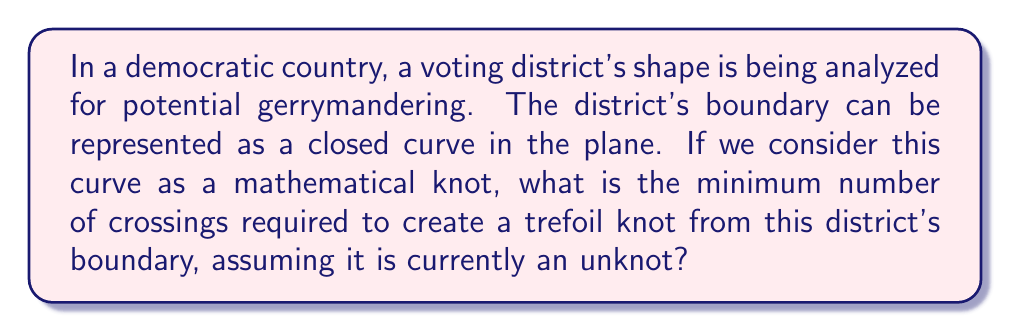Teach me how to tackle this problem. To approach this problem, we need to consider the following steps:

1. Understand the current state:
   The district's boundary is represented as an unknot, which is a simple closed curve with no crossings.

2. Define the goal:
   We want to transform the unknot into a trefoil knot, which is the simplest non-trivial knot.

3. Recall the properties of a trefoil knot:
   A trefoil knot has a minimum crossing number of 3. This means that in any projection of the trefoil knot onto a plane, there will be at least 3 crossings.

4. Consider the transformation:
   To change the unknot into a trefoil knot, we need to introduce crossings. Each crossing requires two separate parts of the curve to intersect.

5. Calculate the minimum number of crossings:
   Since the trefoil knot has a minimum crossing number of 3, and we're starting from an unknot (which has 0 crossings), we need to add at least 3 crossings to create a trefoil knot.

6. Interpret in the context of voting districts:
   In terms of the voting district, this means we would need to modify the boundary in at least three places to create a shape that is topologically equivalent to a trefoil knot.

The mathematical representation of this transformation can be expressed as:

$$K_{trefoil} = K_{unknot} + 3C$$

Where $K_{trefoil}$ represents the trefoil knot, $K_{unknot}$ represents the initial unknot (the original district boundary), and $C$ represents a crossing.
Answer: 3 crossings 